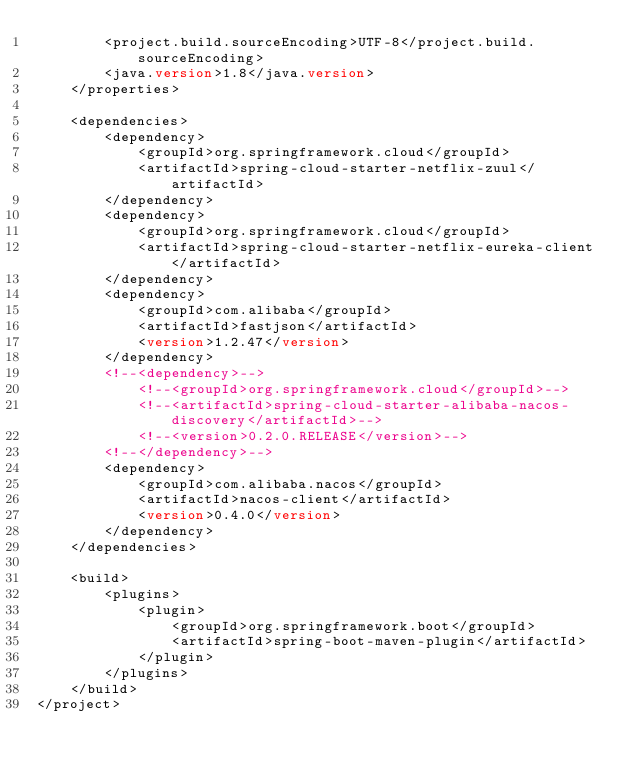<code> <loc_0><loc_0><loc_500><loc_500><_XML_>		<project.build.sourceEncoding>UTF-8</project.build.sourceEncoding>
		<java.version>1.8</java.version>
	</properties>

	<dependencies>
		<dependency>
			<groupId>org.springframework.cloud</groupId>
			<artifactId>spring-cloud-starter-netflix-zuul</artifactId>
		</dependency>
		<dependency>
			<groupId>org.springframework.cloud</groupId>
			<artifactId>spring-cloud-starter-netflix-eureka-client</artifactId>
		</dependency>
		<dependency>
			<groupId>com.alibaba</groupId>
			<artifactId>fastjson</artifactId>
			<version>1.2.47</version>
		</dependency>
		<!--<dependency>-->
			<!--<groupId>org.springframework.cloud</groupId>-->
			<!--<artifactId>spring-cloud-starter-alibaba-nacos-discovery</artifactId>-->
			<!--<version>0.2.0.RELEASE</version>-->
		<!--</dependency>-->
		<dependency>
			<groupId>com.alibaba.nacos</groupId>
			<artifactId>nacos-client</artifactId>
			<version>0.4.0</version>
		</dependency>
	</dependencies>

	<build>
		<plugins>
			<plugin>
				<groupId>org.springframework.boot</groupId>
				<artifactId>spring-boot-maven-plugin</artifactId>
			</plugin>
		</plugins>
	</build>
</project></code> 